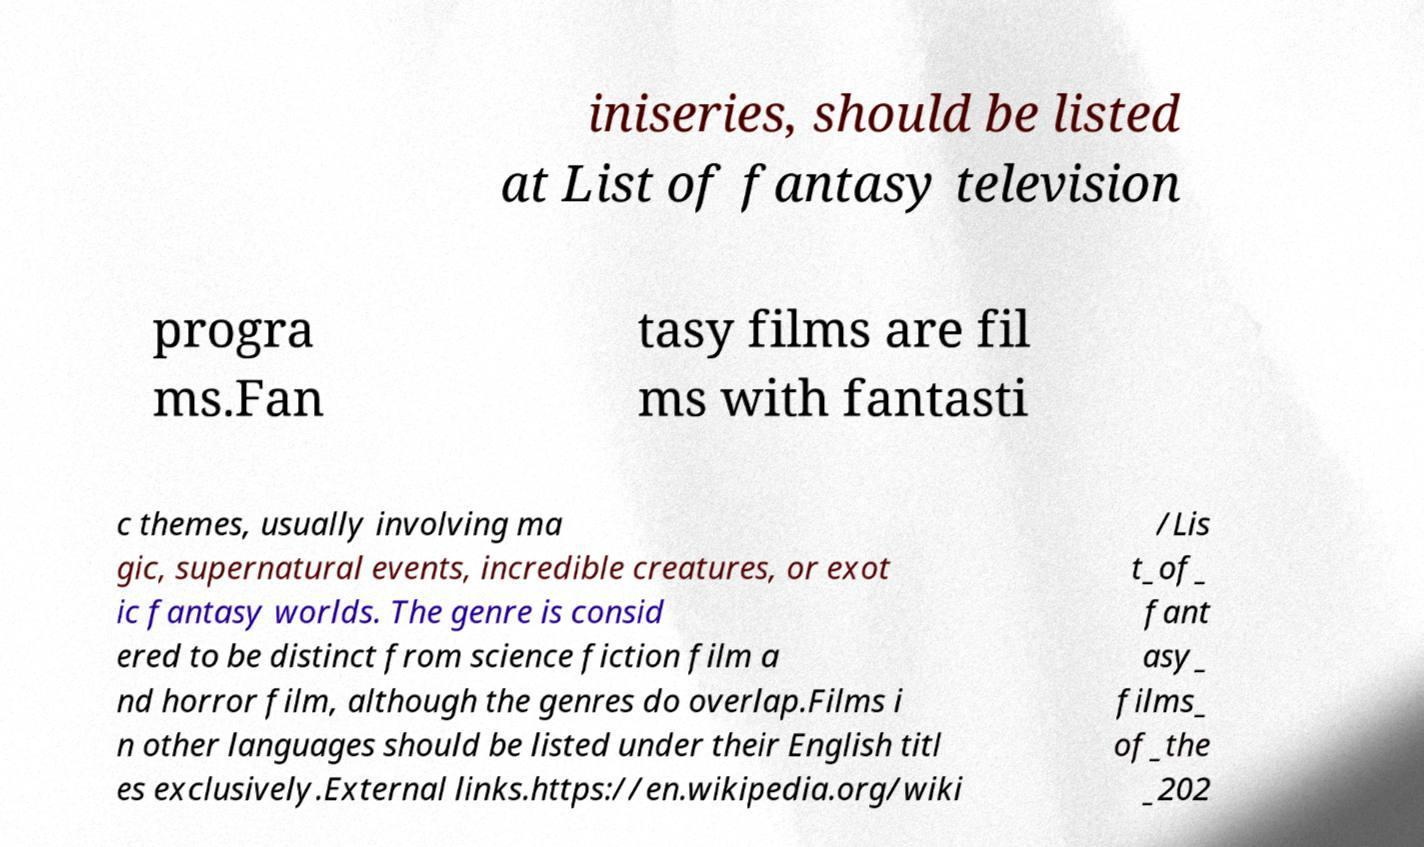Please identify and transcribe the text found in this image. iniseries, should be listed at List of fantasy television progra ms.Fan tasy films are fil ms with fantasti c themes, usually involving ma gic, supernatural events, incredible creatures, or exot ic fantasy worlds. The genre is consid ered to be distinct from science fiction film a nd horror film, although the genres do overlap.Films i n other languages should be listed under their English titl es exclusively.External links.https://en.wikipedia.org/wiki /Lis t_of_ fant asy_ films_ of_the _202 